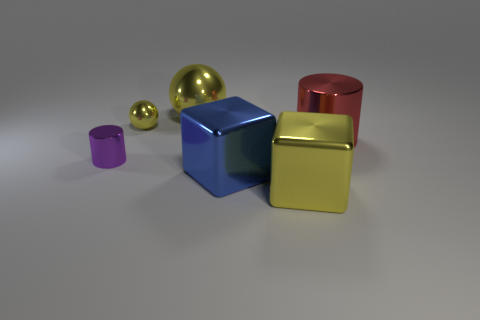Add 4 tiny brown matte spheres. How many objects exist? 10 Subtract all cubes. How many objects are left? 4 Subtract all small things. Subtract all tiny yellow balls. How many objects are left? 3 Add 1 large yellow shiny cubes. How many large yellow shiny cubes are left? 2 Add 1 cyan matte things. How many cyan matte things exist? 1 Subtract 0 blue balls. How many objects are left? 6 